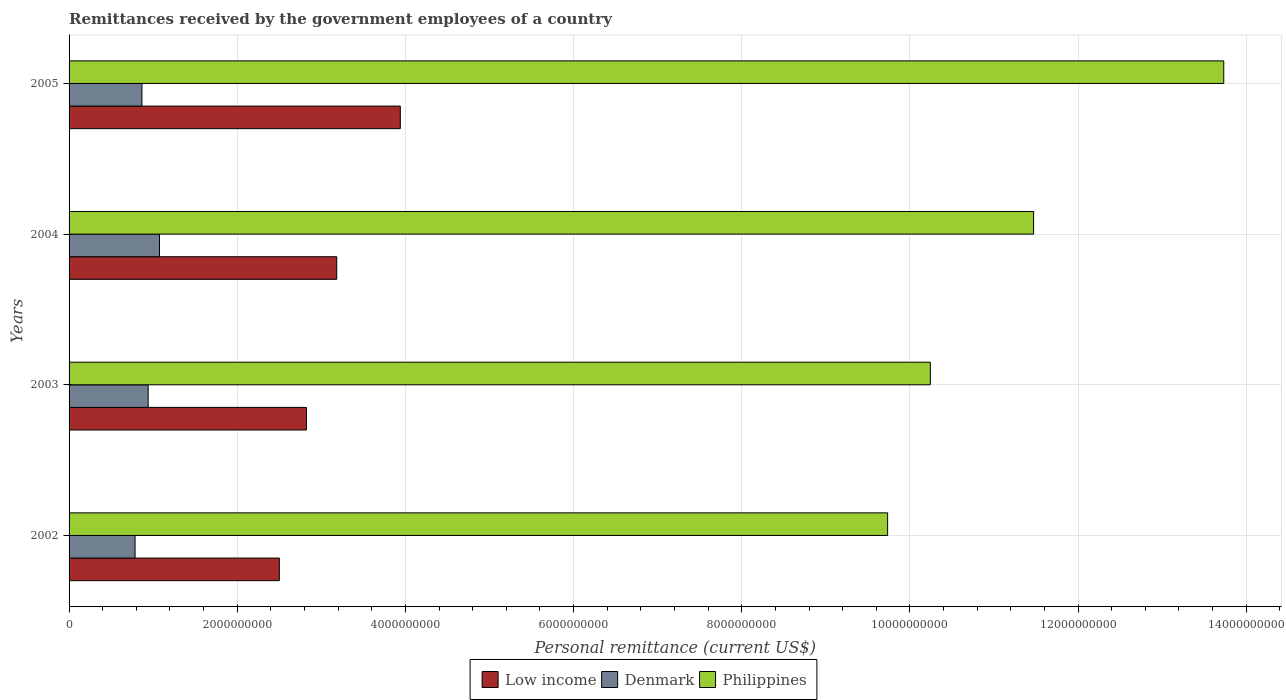How many different coloured bars are there?
Ensure brevity in your answer.  3. How many bars are there on the 2nd tick from the bottom?
Your answer should be compact. 3. In how many cases, is the number of bars for a given year not equal to the number of legend labels?
Your response must be concise. 0. What is the remittances received by the government employees in Philippines in 2002?
Your answer should be very brief. 9.74e+09. Across all years, what is the maximum remittances received by the government employees in Denmark?
Your answer should be compact. 1.08e+09. Across all years, what is the minimum remittances received by the government employees in Philippines?
Your answer should be compact. 9.74e+09. In which year was the remittances received by the government employees in Philippines minimum?
Give a very brief answer. 2002. What is the total remittances received by the government employees in Low income in the graph?
Your response must be concise. 1.24e+1. What is the difference between the remittances received by the government employees in Philippines in 2003 and that in 2004?
Keep it short and to the point. -1.23e+09. What is the difference between the remittances received by the government employees in Low income in 2004 and the remittances received by the government employees in Philippines in 2003?
Your response must be concise. -7.06e+09. What is the average remittances received by the government employees in Philippines per year?
Your response must be concise. 1.13e+1. In the year 2003, what is the difference between the remittances received by the government employees in Philippines and remittances received by the government employees in Low income?
Keep it short and to the point. 7.42e+09. What is the ratio of the remittances received by the government employees in Denmark in 2004 to that in 2005?
Offer a very short reply. 1.24. Is the difference between the remittances received by the government employees in Philippines in 2002 and 2004 greater than the difference between the remittances received by the government employees in Low income in 2002 and 2004?
Keep it short and to the point. No. What is the difference between the highest and the second highest remittances received by the government employees in Philippines?
Provide a short and direct response. 2.26e+09. What is the difference between the highest and the lowest remittances received by the government employees in Low income?
Ensure brevity in your answer.  1.44e+09. Is the sum of the remittances received by the government employees in Low income in 2003 and 2004 greater than the maximum remittances received by the government employees in Philippines across all years?
Your answer should be compact. No. What does the 2nd bar from the bottom in 2004 represents?
Offer a very short reply. Denmark. Are all the bars in the graph horizontal?
Offer a very short reply. Yes. What is the difference between two consecutive major ticks on the X-axis?
Ensure brevity in your answer.  2.00e+09. Does the graph contain any zero values?
Make the answer very short. No. Where does the legend appear in the graph?
Keep it short and to the point. Bottom center. How many legend labels are there?
Provide a short and direct response. 3. What is the title of the graph?
Give a very brief answer. Remittances received by the government employees of a country. What is the label or title of the X-axis?
Keep it short and to the point. Personal remittance (current US$). What is the Personal remittance (current US$) in Low income in 2002?
Your answer should be very brief. 2.50e+09. What is the Personal remittance (current US$) in Denmark in 2002?
Your response must be concise. 7.85e+08. What is the Personal remittance (current US$) in Philippines in 2002?
Keep it short and to the point. 9.74e+09. What is the Personal remittance (current US$) of Low income in 2003?
Your response must be concise. 2.82e+09. What is the Personal remittance (current US$) of Denmark in 2003?
Your answer should be compact. 9.41e+08. What is the Personal remittance (current US$) in Philippines in 2003?
Offer a very short reply. 1.02e+1. What is the Personal remittance (current US$) in Low income in 2004?
Your response must be concise. 3.18e+09. What is the Personal remittance (current US$) of Denmark in 2004?
Give a very brief answer. 1.08e+09. What is the Personal remittance (current US$) in Philippines in 2004?
Your answer should be very brief. 1.15e+1. What is the Personal remittance (current US$) of Low income in 2005?
Ensure brevity in your answer.  3.94e+09. What is the Personal remittance (current US$) of Denmark in 2005?
Provide a short and direct response. 8.67e+08. What is the Personal remittance (current US$) in Philippines in 2005?
Make the answer very short. 1.37e+1. Across all years, what is the maximum Personal remittance (current US$) in Low income?
Make the answer very short. 3.94e+09. Across all years, what is the maximum Personal remittance (current US$) in Denmark?
Give a very brief answer. 1.08e+09. Across all years, what is the maximum Personal remittance (current US$) in Philippines?
Offer a terse response. 1.37e+1. Across all years, what is the minimum Personal remittance (current US$) in Low income?
Offer a terse response. 2.50e+09. Across all years, what is the minimum Personal remittance (current US$) in Denmark?
Keep it short and to the point. 7.85e+08. Across all years, what is the minimum Personal remittance (current US$) of Philippines?
Give a very brief answer. 9.74e+09. What is the total Personal remittance (current US$) of Low income in the graph?
Your response must be concise. 1.24e+1. What is the total Personal remittance (current US$) of Denmark in the graph?
Give a very brief answer. 3.67e+09. What is the total Personal remittance (current US$) of Philippines in the graph?
Your answer should be compact. 4.52e+1. What is the difference between the Personal remittance (current US$) in Low income in 2002 and that in 2003?
Your response must be concise. -3.23e+08. What is the difference between the Personal remittance (current US$) in Denmark in 2002 and that in 2003?
Make the answer very short. -1.56e+08. What is the difference between the Personal remittance (current US$) of Philippines in 2002 and that in 2003?
Your response must be concise. -5.08e+08. What is the difference between the Personal remittance (current US$) of Low income in 2002 and that in 2004?
Your answer should be compact. -6.83e+08. What is the difference between the Personal remittance (current US$) of Denmark in 2002 and that in 2004?
Offer a very short reply. -2.91e+08. What is the difference between the Personal remittance (current US$) in Philippines in 2002 and that in 2004?
Make the answer very short. -1.74e+09. What is the difference between the Personal remittance (current US$) of Low income in 2002 and that in 2005?
Make the answer very short. -1.44e+09. What is the difference between the Personal remittance (current US$) of Denmark in 2002 and that in 2005?
Offer a terse response. -8.19e+07. What is the difference between the Personal remittance (current US$) in Philippines in 2002 and that in 2005?
Ensure brevity in your answer.  -4.00e+09. What is the difference between the Personal remittance (current US$) in Low income in 2003 and that in 2004?
Your answer should be very brief. -3.60e+08. What is the difference between the Personal remittance (current US$) of Denmark in 2003 and that in 2004?
Your answer should be very brief. -1.35e+08. What is the difference between the Personal remittance (current US$) in Philippines in 2003 and that in 2004?
Your answer should be compact. -1.23e+09. What is the difference between the Personal remittance (current US$) in Low income in 2003 and that in 2005?
Provide a succinct answer. -1.12e+09. What is the difference between the Personal remittance (current US$) of Denmark in 2003 and that in 2005?
Offer a very short reply. 7.38e+07. What is the difference between the Personal remittance (current US$) in Philippines in 2003 and that in 2005?
Make the answer very short. -3.49e+09. What is the difference between the Personal remittance (current US$) of Low income in 2004 and that in 2005?
Provide a short and direct response. -7.56e+08. What is the difference between the Personal remittance (current US$) of Denmark in 2004 and that in 2005?
Offer a very short reply. 2.09e+08. What is the difference between the Personal remittance (current US$) of Philippines in 2004 and that in 2005?
Your answer should be compact. -2.26e+09. What is the difference between the Personal remittance (current US$) in Low income in 2002 and the Personal remittance (current US$) in Denmark in 2003?
Your response must be concise. 1.56e+09. What is the difference between the Personal remittance (current US$) of Low income in 2002 and the Personal remittance (current US$) of Philippines in 2003?
Keep it short and to the point. -7.74e+09. What is the difference between the Personal remittance (current US$) of Denmark in 2002 and the Personal remittance (current US$) of Philippines in 2003?
Keep it short and to the point. -9.46e+09. What is the difference between the Personal remittance (current US$) of Low income in 2002 and the Personal remittance (current US$) of Denmark in 2004?
Keep it short and to the point. 1.43e+09. What is the difference between the Personal remittance (current US$) in Low income in 2002 and the Personal remittance (current US$) in Philippines in 2004?
Give a very brief answer. -8.97e+09. What is the difference between the Personal remittance (current US$) in Denmark in 2002 and the Personal remittance (current US$) in Philippines in 2004?
Provide a short and direct response. -1.07e+1. What is the difference between the Personal remittance (current US$) in Low income in 2002 and the Personal remittance (current US$) in Denmark in 2005?
Offer a terse response. 1.63e+09. What is the difference between the Personal remittance (current US$) in Low income in 2002 and the Personal remittance (current US$) in Philippines in 2005?
Provide a short and direct response. -1.12e+1. What is the difference between the Personal remittance (current US$) in Denmark in 2002 and the Personal remittance (current US$) in Philippines in 2005?
Your answer should be compact. -1.29e+1. What is the difference between the Personal remittance (current US$) of Low income in 2003 and the Personal remittance (current US$) of Denmark in 2004?
Your response must be concise. 1.75e+09. What is the difference between the Personal remittance (current US$) of Low income in 2003 and the Personal remittance (current US$) of Philippines in 2004?
Offer a terse response. -8.65e+09. What is the difference between the Personal remittance (current US$) of Denmark in 2003 and the Personal remittance (current US$) of Philippines in 2004?
Offer a very short reply. -1.05e+1. What is the difference between the Personal remittance (current US$) of Low income in 2003 and the Personal remittance (current US$) of Denmark in 2005?
Offer a terse response. 1.96e+09. What is the difference between the Personal remittance (current US$) in Low income in 2003 and the Personal remittance (current US$) in Philippines in 2005?
Your response must be concise. -1.09e+1. What is the difference between the Personal remittance (current US$) in Denmark in 2003 and the Personal remittance (current US$) in Philippines in 2005?
Offer a very short reply. -1.28e+1. What is the difference between the Personal remittance (current US$) of Low income in 2004 and the Personal remittance (current US$) of Denmark in 2005?
Offer a terse response. 2.32e+09. What is the difference between the Personal remittance (current US$) of Low income in 2004 and the Personal remittance (current US$) of Philippines in 2005?
Ensure brevity in your answer.  -1.05e+1. What is the difference between the Personal remittance (current US$) in Denmark in 2004 and the Personal remittance (current US$) in Philippines in 2005?
Your answer should be very brief. -1.27e+1. What is the average Personal remittance (current US$) in Low income per year?
Your answer should be very brief. 3.11e+09. What is the average Personal remittance (current US$) in Denmark per year?
Provide a succinct answer. 9.17e+08. What is the average Personal remittance (current US$) of Philippines per year?
Provide a succinct answer. 1.13e+1. In the year 2002, what is the difference between the Personal remittance (current US$) of Low income and Personal remittance (current US$) of Denmark?
Provide a succinct answer. 1.72e+09. In the year 2002, what is the difference between the Personal remittance (current US$) of Low income and Personal remittance (current US$) of Philippines?
Give a very brief answer. -7.23e+09. In the year 2002, what is the difference between the Personal remittance (current US$) in Denmark and Personal remittance (current US$) in Philippines?
Keep it short and to the point. -8.95e+09. In the year 2003, what is the difference between the Personal remittance (current US$) of Low income and Personal remittance (current US$) of Denmark?
Ensure brevity in your answer.  1.88e+09. In the year 2003, what is the difference between the Personal remittance (current US$) of Low income and Personal remittance (current US$) of Philippines?
Make the answer very short. -7.42e+09. In the year 2003, what is the difference between the Personal remittance (current US$) of Denmark and Personal remittance (current US$) of Philippines?
Provide a short and direct response. -9.30e+09. In the year 2004, what is the difference between the Personal remittance (current US$) in Low income and Personal remittance (current US$) in Denmark?
Your answer should be compact. 2.11e+09. In the year 2004, what is the difference between the Personal remittance (current US$) in Low income and Personal remittance (current US$) in Philippines?
Provide a short and direct response. -8.29e+09. In the year 2004, what is the difference between the Personal remittance (current US$) of Denmark and Personal remittance (current US$) of Philippines?
Offer a terse response. -1.04e+1. In the year 2005, what is the difference between the Personal remittance (current US$) of Low income and Personal remittance (current US$) of Denmark?
Offer a very short reply. 3.07e+09. In the year 2005, what is the difference between the Personal remittance (current US$) of Low income and Personal remittance (current US$) of Philippines?
Provide a succinct answer. -9.79e+09. In the year 2005, what is the difference between the Personal remittance (current US$) in Denmark and Personal remittance (current US$) in Philippines?
Provide a succinct answer. -1.29e+1. What is the ratio of the Personal remittance (current US$) in Low income in 2002 to that in 2003?
Make the answer very short. 0.89. What is the ratio of the Personal remittance (current US$) in Denmark in 2002 to that in 2003?
Your response must be concise. 0.83. What is the ratio of the Personal remittance (current US$) in Philippines in 2002 to that in 2003?
Keep it short and to the point. 0.95. What is the ratio of the Personal remittance (current US$) in Low income in 2002 to that in 2004?
Offer a very short reply. 0.79. What is the ratio of the Personal remittance (current US$) of Denmark in 2002 to that in 2004?
Keep it short and to the point. 0.73. What is the ratio of the Personal remittance (current US$) of Philippines in 2002 to that in 2004?
Your answer should be compact. 0.85. What is the ratio of the Personal remittance (current US$) in Low income in 2002 to that in 2005?
Provide a succinct answer. 0.63. What is the ratio of the Personal remittance (current US$) of Denmark in 2002 to that in 2005?
Offer a very short reply. 0.91. What is the ratio of the Personal remittance (current US$) of Philippines in 2002 to that in 2005?
Make the answer very short. 0.71. What is the ratio of the Personal remittance (current US$) of Low income in 2003 to that in 2004?
Your response must be concise. 0.89. What is the ratio of the Personal remittance (current US$) in Denmark in 2003 to that in 2004?
Give a very brief answer. 0.87. What is the ratio of the Personal remittance (current US$) in Philippines in 2003 to that in 2004?
Your answer should be very brief. 0.89. What is the ratio of the Personal remittance (current US$) in Low income in 2003 to that in 2005?
Offer a terse response. 0.72. What is the ratio of the Personal remittance (current US$) in Denmark in 2003 to that in 2005?
Offer a terse response. 1.09. What is the ratio of the Personal remittance (current US$) of Philippines in 2003 to that in 2005?
Give a very brief answer. 0.75. What is the ratio of the Personal remittance (current US$) in Low income in 2004 to that in 2005?
Your response must be concise. 0.81. What is the ratio of the Personal remittance (current US$) in Denmark in 2004 to that in 2005?
Give a very brief answer. 1.24. What is the ratio of the Personal remittance (current US$) in Philippines in 2004 to that in 2005?
Give a very brief answer. 0.84. What is the difference between the highest and the second highest Personal remittance (current US$) of Low income?
Your answer should be compact. 7.56e+08. What is the difference between the highest and the second highest Personal remittance (current US$) in Denmark?
Your response must be concise. 1.35e+08. What is the difference between the highest and the second highest Personal remittance (current US$) in Philippines?
Your response must be concise. 2.26e+09. What is the difference between the highest and the lowest Personal remittance (current US$) in Low income?
Keep it short and to the point. 1.44e+09. What is the difference between the highest and the lowest Personal remittance (current US$) in Denmark?
Keep it short and to the point. 2.91e+08. What is the difference between the highest and the lowest Personal remittance (current US$) in Philippines?
Offer a terse response. 4.00e+09. 